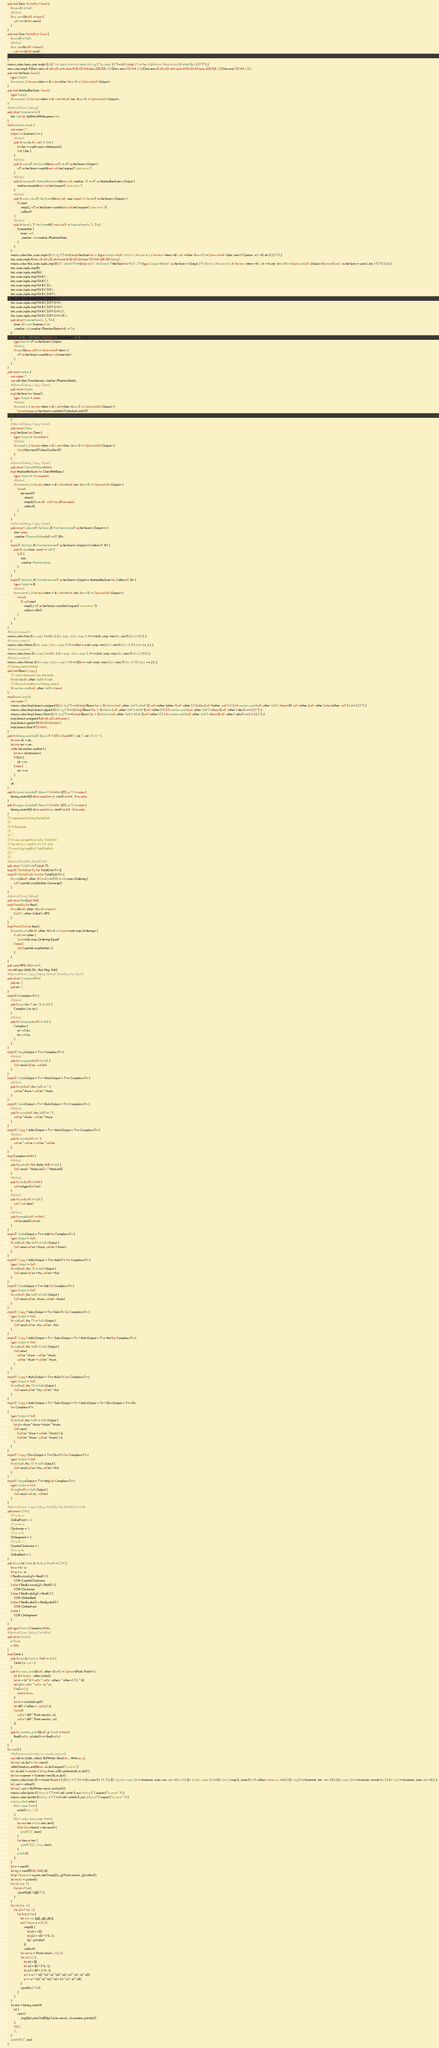<code> <loc_0><loc_0><loc_500><loc_500><_Rust_>pub trait Zero: PartialEq + Sized {
    fn zero() -> Self;
    #[inline]
    fn is_zero(&self) -> bool {
        self == &Self::zero()
    }
}
pub trait One: PartialEq + Sized {
    fn one() -> Self;
    #[inline]
    fn is_one(&self) -> bool {
        self == &Self::one()
    }
}
macro_rules !zero_one_impls {($({$Trait :ident $method :ident $($t :ty ) *,$e :expr } ) *) =>{$($(impl $Trait for $t {#[inline ] fn $method () ->Self {$e } } ) *) *} ;}
zero_one_impls !({Zero zero u8 u16 u32 u64 usize i8 i16 i32 i64 isize u128 i128 ,0 } {Zero zero f32 f64 ,0. } {One one u8 u16 u32 u64 usize i8 i16 i32 i64 isize u128 i128 ,1 } {One one f32 f64 ,1. } ) ;
pub trait IterScan: Sized {
    type Output;
    fn scan<'a, I: Iterator<Item = &'a str>>(iter: &mut I) -> Option<Self::Output>;
}
pub trait MarkedIterScan: Sized {
    type Output;
    fn mscan<'a, I: Iterator<Item = &'a str>>(self, iter: &mut I) -> Option<Self::Output>;
}
#[derive(Clone, Debug)]
pub struct Scanner<'a> {
    iter: std::str::SplitAsciiWhitespace<'a>,
}
mod scanner_impls {
    use super::*;
    impl<'a> Scanner<'a> {
        #[inline]
        pub fn new(s: &'a str) -> Self {
            let iter = s.split_ascii_whitespace();
            Self { iter }
        }
        #[inline]
        pub fn scan<T: IterScan>(&mut self) -> <T as IterScan>::Output {
            <T as IterScan>::scan(&mut self.iter).expect("scan error")
        }
        #[inline]
        pub fn mscan<T: MarkedIterScan>(&mut self, marker: T) -> <T as MarkedIterScan>::Output {
            marker.mscan(&mut self.iter).expect("scan error")
        }
        #[inline]
        pub fn scan_vec<T: IterScan>(&mut self, size: usize) -> Vec<<T as IterScan>::Output> {
            (0..size)
                .map(|_| <T as IterScan>::scan(&mut self.iter).expect("scan error"))
                .collect()
        }
        #[inline]
        pub fn iter<'b, T: IterScan>(&'b mut self) -> ScannerIter<'a, 'b, T> {
            ScannerIter {
                inner: self,
                _marker: std::marker::PhantomData,
            }
        }
    }
    macro_rules !iter_scan_impls {($($t :ty ) *) =>{$(impl IterScan for $t {type Output =Self ;#[inline ] fn scan <'a ,I :Iterator <Item =&'a str >>(iter :&mut I ) ->Option <Self >{iter .next () ?.parse ::<$t >() .ok () } } ) *} ;}
    iter_scan_impls !(char u8 u16 u32 u64 usize i8 i16 i32 i64 isize f32 f64 u128 i128 String ) ;
    macro_rules !iter_scan_tuple_impl {($($T :ident ) *) =>{impl <$($T :IterScan ) ,*>IterScan for ($($T ,) *) {type Output =($(<$T as IterScan >::Output ,) *) ;#[inline ] fn scan <'a ,It :Iterator <Item =&'a str >>(_iter :&mut It ) ->Option <Self ::Output >{Some (($(<$T as IterScan >::scan (_iter ) ?,) *) ) } } } ;}
    iter_scan_tuple_impl!();
    iter_scan_tuple_impl!(A);
    iter_scan_tuple_impl !(A B ) ;
    iter_scan_tuple_impl !(A B C ) ;
    iter_scan_tuple_impl !(A B C D ) ;
    iter_scan_tuple_impl !(A B C D E ) ;
    iter_scan_tuple_impl !(A B C D E F ) ;
    iter_scan_tuple_impl !(A B C D E F G ) ;
    iter_scan_tuple_impl !(A B C D E F G H ) ;
    iter_scan_tuple_impl !(A B C D E F G H I ) ;
    iter_scan_tuple_impl !(A B C D E F G H I J ) ;
    iter_scan_tuple_impl !(A B C D E F G H I J K ) ;
    pub struct ScannerIter<'a, 'b, T> {
        inner: &'b mut Scanner<'a>,
        _marker: std::marker::PhantomData<fn() -> T>,
    }
    impl<'a, 'b, T: IterScan> Iterator for ScannerIter<'a, 'b, T> {
        type Item = <T as IterScan>::Output;
        #[inline]
        fn next(&mut self) -> Option<Self::Item> {
            <T as IterScan>::scan(&mut self.inner.iter)
        }
    }
}
pub mod marker {
    use super::*;
    use std::{iter::FromIterator, marker::PhantomData};
    #[derive(Debug, Copy, Clone)]
    pub struct Usize1;
    impl IterScan for Usize1 {
        type Output = usize;
        #[inline]
        fn scan<'a, I: Iterator<Item = &'a str>>(iter: &mut I) -> Option<Self::Output> {
            Some(<usize as IterScan>::scan(iter)?.checked_sub(1)?)
        }
    }
    #[derive(Debug, Copy, Clone)]
    pub struct Chars;
    impl IterScan for Chars {
        type Output = Vec<char>;
        #[inline]
        fn scan<'a, I: Iterator<Item = &'a str>>(iter: &mut I) -> Option<Self::Output> {
            Some(iter.next()?.chars().collect())
        }
    }
    #[derive(Debug, Copy, Clone)]
    pub struct CharsWithBase(char);
    impl MarkedIterScan for CharsWithBase {
        type Output = Vec<usize>;
        #[inline]
        fn mscan<'a, I: Iterator<Item = &'a str>>(self, iter: &mut I) -> Option<Self::Output> {
            Some(
                iter.next()?
                    .chars()
                    .map(|c| (c as u8 - self.0 as u8) as usize)
                    .collect(),
            )
        }
    }
    #[derive(Debug, Copy, Clone)]
    pub struct Collect<T: IterScan, B: FromIterator<<T as IterScan>::Output>> {
        size: usize,
        _marker: PhantomData<fn() -> (T, B)>,
    }
    impl<T: IterScan, B: FromIterator<<T as IterScan>::Output>> Collect<T, B> {
        pub fn new(size: usize) -> Self {
            Self {
                size,
                _marker: PhantomData,
            }
        }
    }
    impl<T: IterScan, B: FromIterator<<T as IterScan>::Output>> MarkedIterScan for Collect<T, B> {
        type Output = B;
        #[inline]
        fn mscan<'a, I: Iterator<Item = &'a str>>(self, iter: &mut I) -> Option<Self::Output> {
            Some(
                (0..self.size)
                    .map(|_| <T as IterScan>::scan(iter).expect("scan error"))
                    .collect::<B>(),
            )
        }
    }
}
#[macro_export]
macro_rules !min {($e :expr ) =>{$e } ;($e :expr ,$($es :expr ) ,+) =>{std ::cmp ::min ($e ,min !($($es ) ,+) ) } ;}
#[macro_export]
macro_rules !chmin {($dst :expr ,$($src :expr ) ,+) =>{{let x =std ::cmp ::min ($dst ,min !($($src ) ,+) ) ;$dst =x ;} } ;}
#[macro_export]
macro_rules !max {($e :expr ) =>{$e } ;($e :expr ,$($es :expr ) ,+) =>{std ::cmp ::max ($e ,max !($($es ) ,+) ) } ;}
#[macro_export]
macro_rules !chmax {($dst :expr ,$($src :expr ) ,+) =>{{let x =std ::cmp ::max ($dst ,max !($($src ) ,+) ) ;$dst =x ;} } ;}
/// binary search helper
pub trait Bisect: Copy {
    /// return between two elements
    fn halve(self, other: Self) -> Self;
    /// the end condition of binary search
    fn section_end(self, other: Self) -> bool;
}
mod bisect_impl {
    use super::*;
    macro_rules !impl_bisect_unsigned {($($t :ty ) *) =>{$(impl Bisect for $t {fn halve (self ,other :Self ) ->Self {if self >other {other +(self -other ) /2 } else {self +(other -self ) /2 } } fn section_end (self ,other :Self ) ->bool {(if self >other {self -other } else {other -self } ) <=1 } } ) *} ;}
    macro_rules !impl_bisect_signed {($($t :ty ) *) =>{$(impl Bisect for $t {fn halve (self ,other :Self ) ->Self {(self +other ) /2 } fn section_end (self ,other :Self ) ->bool {(self -other ) .abs () <=1 } } ) *} ;}
    macro_rules !impl_bisect_float {($($t :ty ) *) =>{$(impl Bisect for $t {fn halve (self ,other :Self ) ->Self {(self +other ) /2. } fn section_end (self ,other :Self ) ->bool {(self -other ) .abs () <=1e-8 } } ) *} ;}
    impl_bisect_unsigned !(u8 u16 u32 u64 usize ) ;
    impl_bisect_signed !(i8 i16 i32 i64 isize ) ;
    impl_bisect_float !(f32 f64 ) ;
}
pub fn binary_search<T: Bisect, F: Fn(T) -> bool>(f: F, ok: T, err: T) -> T {
    let mut ok = ok;
    let mut err = err;
    while !ok.section_end(err) {
        let m = ok.halve(err);
        if f(m) {
            ok = m;
        } else {
            err = m;
        }
    }
    ok
}
pub fn lower_bound<T: Bisect + Ord>(v: &[T], x: T) -> usize {
    binary_search(|i| v[i as usize] >= x, v.len() as i64, -1) as usize
}
pub fn upper_bound<T: Bisect + Ord>(v: &[T], x: T) -> usize {
    binary_search(|i| v[i as usize] > x, v.len() as i64, -1) as usize
}
/// implement Ord by PartialOrd
///
/// # Example
///
/// ```
/// # use competitive::tools::TotalOrd;
/// let mut a = vec![3.1, 4.1, 5.9, 2.6];
/// a.sort_by_key(|&x| TotalOrd(x));
/// ```
///
#[derive(PartialEq, PartialOrd)]
pub struct TotalOrd<T>(pub T);
impl<T: PartialEq> Eq for TotalOrd<T> {}
impl<T: PartialOrd> Ord for TotalOrd<T> {
    fn cmp(&self, other: &TotalOrd<T>) -> std::cmp::Ordering {
        self.0.partial_cmp(&other.0).unwrap()
    }
}
#[derive(Clone, Debug)]
pub struct Real(pub f64);
impl PartialEq for Real {
    fn eq(&self, other: &Real) -> bool {
        (self.0 - other.0).abs() < EPS
    }
}
impl PartialOrd for Real {
    fn partial_cmp(&self, other: &Real) -> Option<std::cmp::Ordering> {
        if self == other {
            Some(std::cmp::Ordering::Equal)
        } else {
            self.0.partial_cmp(&other.0)
        }
    }
}
pub const EPS: f64 = 1e-8;
use std::ops::{Add, Div, Mul, Neg, Sub};
#[derive(Clone, Copy, Debug, Default, PartialEq, Eq, Hash)]
pub struct Complex<T> {
    pub re: T,
    pub im: T,
}
impl<T> Complex<T> {
    #[inline]
    pub fn new(re: T, im: T) -> Self {
        Complex { re, im }
    }
    #[inline]
    pub fn transpose(self) -> Self {
        Complex {
            re: self.im,
            im: self.re,
        }
    }
}
impl<T: Neg<Output = T>> Complex<T> {
    #[inline]
    pub fn conjugate(self) -> Self {
        Self::new(self.re, -self.im)
    }
}
impl<T: Add<Output = T> + Mul<Output = T>> Complex<T> {
    #[inline]
    pub fn dot(self, rhs: Self) -> T {
        self.re * rhs.re + self.im * rhs.im
    }
}
impl<T: Sub<Output = T> + Mul<Output = T>> Complex<T> {
    #[inline]
    pub fn cross(self, rhs: Self) -> T {
        self.re * rhs.im - self.im * rhs.re
    }
}
impl<T: Copy + Add<Output = T> + Mul<Output = T>> Complex<T> {
    #[inline]
    pub fn norm(self) -> T {
        self.re * self.re + self.im * self.im
    }
}
impl Complex<f64> {
    #[inline]
    pub fn polar(r: f64, theta: f64) -> Self {
        Self::new(r * theta.cos(), r * theta.sin())
    }
    #[inline]
    pub fn abs(self) -> f64 {
        self.re.hypot(self.im)
    }
    #[inline]
    pub fn unit(self) -> Self {
        self / self.abs()
    }
    #[inline]
    pub fn angle(self) -> f64 {
        self.im.atan2(self.re)
    }
}
impl<T: Add<Output = T>> Add for Complex<T> {
    type Output = Self;
    fn add(self, rhs: Self) -> Self::Output {
        Self::new(self.re + rhs.re, self.im + rhs.im)
    }
}
impl<T: Copy + Add<Output = T>> Add<T> for Complex<T> {
    type Output = Self;
    fn add(self, rhs: T) -> Self::Output {
        Self::new(self.re + rhs, self.im + rhs)
    }
}
impl<T: Sub<Output = T>> Sub for Complex<T> {
    type Output = Self;
    fn sub(self, rhs: Self) -> Self::Output {
        Self::new(self.re - rhs.re, self.im - rhs.im)
    }
}
impl<T: Copy + Sub<Output = T>> Sub<T> for Complex<T> {
    type Output = Self;
    fn sub(self, rhs: T) -> Self::Output {
        Self::new(self.re - rhs, self.im - rhs)
    }
}
impl<T: Copy + Add<Output = T> + Sub<Output = T> + Mul<Output = T>> Mul for Complex<T> {
    type Output = Self;
    fn mul(self, rhs: Self) -> Self::Output {
        Self::new(
            self.re * rhs.re - self.im * rhs.im,
            self.re * rhs.im + self.im * rhs.re,
        )
    }
}
impl<T: Copy + Mul<Output = T>> Mul<T> for Complex<T> {
    type Output = Self;
    fn mul(self, rhs: T) -> Self::Output {
        Self::new(self.re * rhs, self.im * rhs)
    }
}
impl<T: Copy + Add<Output = T> + Sub<Output = T> + Mul<Output = T> + Div<Output = T>> Div
    for Complex<T>
{
    type Output = Self;
    fn div(self, rhs: Self) -> Self::Output {
        let d = rhs.re * rhs.re + rhs.im * rhs.im;
        Self::new(
            (self.re * rhs.re + self.im * rhs.im) / d,
            (self.im * rhs.re - self.re * rhs.im) / d,
        )
    }
}
impl<T: Copy + Div<Output = T>> Div<T> for Complex<T> {
    type Output = Self;
    fn div(self, rhs: T) -> Self::Output {
        Self::new(self.re / rhs, self.im / rhs)
    }
}
impl<T: Neg<Output = T>> Neg for Complex<T> {
    type Output = Self;
    fn neg(self) -> Self::Output {
        Self::new(-self.re, -self.im)
    }
}
#[derive(Clone, Copy, Debug, PartialEq, Eq, PartialOrd, Ord)]
pub enum CCW {
    /// a--b--c
    OnlineFront = -2,
    /// a--b-vc
    Clockwise = -1,
    /// a--c--b
    OnSegment = 0,
    /// a--b-^c
    CounterClockwise = 1,
    /// c--a--b
    OnlineBack = 2,
}
pub fn ccw(a: Point, b: Point, c: Point) -> CCW {
    let x = b - a;
    let y = c - a;
    if Real(x.cross(y)) > Real(0.) {
        CCW::CounterClockwise
    } else if Real(x.cross(y)) < Real(0.) {
        CCW::Clockwise
    } else if Real(x.dot(y)) < Real(0.) {
        CCW::OnlineBack
    } else if Real(x.abs()) < Real(y.abs()) {
        CCW::OnlineFront
    } else {
        CCW::OnSegment
    }
}
pub type Point = Complex<f64>;
#[derive(Clone, Debug, PartialEq)]
pub struct Circle {
    c: Point,
    r: f64,
}
impl Circle {
    pub fn new(c: Point, r: f64) -> Self {
        Circle { c: c, r: r }
    }
    pub fn cross_circle(&self, other: &Self) -> Option<(Point, Point)> {
        let d = (self.c - other.c).abs();
        let rc = (d * d + self.r * self.r - other.r * other.r) / (2. * d);
        let rs2 = self.r * self.r - rc * rc;
        if rs2 < 0. {
            return None;
        }
        let rs = rs2.abs().sqrt();
        let diff = (other.c - self.c) / d;
        Some((
            self.c + diff * Point::new(rc, rs),
            self.c + diff * Point::new(rc, -rs),
        ))
    }
    pub fn contains_point(&self, p: Point) -> bool {
        Real((self.c - p).abs()) <= Real(self.r)
    }
}
fn main() {
    #![allow(unused_imports, unused_macros)]
    use std::io::{stdin, stdout, BufWriter, Read as _, Write as _};
    let mut _in_buf = Vec::new();
    stdin().read_to_end(&mut _in_buf).expect("io error");
    let _in_buf = unsafe { String::from_utf8_unchecked(_in_buf) };
    let mut scanner = Scanner::new(&_in_buf);
    macro_rules !scan {() =>{scan !(usize ) } ;(($($t :tt ) ,*) ) =>{($(scan !($t ) ) ,*) } ;([$t :ty ;$len :expr ] ) =>{scanner .scan_vec ::<$t >($len ) } ;([$t :tt ;$len :expr ] ) =>{(0 ..$len ) .map (|_ |scan !($t ) ) .collect ::<Vec <_ >>() } ;([$t :ty ] ) =>{scanner .iter ::<$t >() } ;({$e :expr } ) =>{scanner .mscan ($e ) } ;($t :ty ) =>{scanner .scan ::<$t >() } ;}
    let _out = stdout();
    let mut _out = BufWriter::new(_out.lock());
    macro_rules !print {($($arg :tt ) *) =>(::std ::write !(_out ,$($arg ) *) .expect ("io error" ) ) }
    macro_rules !println {($($arg :tt ) *) =>(::std ::writeln !(_out ,$($arg ) *) .expect ("io error" ) ) }
    macro_rules! echo {
        ($iter :expr ) => {
            echo!($iter, '\n')
        };
        ($iter :expr ,$sep :expr ) => {
            let mut iter = $iter.into_iter();
            if let Some(item) = iter.next() {
                print!("{}", item);
            }
            for item in iter {
                print!("{}{}", $sep, item);
            }
            println!();
        };
    }
    let n = scan!();
    let xy = scan!([(f64, f64); n]);
    let p: Vec<_> = xy.into_iter().map(|(x, y)| Point::new(x, y)).collect();
    let mut c = p.clone();
    for i in 0..n - 1 {
        for j in i + 1..n {
            c.push((p[i] + p[j]) / 2.);
        }
    }
    for i in 0..n - 2 {
        for j in i + 1..n - 1 {
            for k in j + 1..n {
                let v = vec![p[i], p[j], p[k]];
                let l: Vec<_> = (0..3)
                    .map(|i| {
                        let p1 = v[i];
                        let p2 = v[(i + 1) % 3];
                        (p1 - p2).abs()
                    })
                    .collect();
                let mut x = (Point::new(0., 0.), 0.);
                for i in 0..3 {
                    let a1 = l[i];
                    let a2 = l[(i + 1) % 3];
                    let a3 = l[(i + 2) % 3];
                    x.0 = x.0 + v[i] * (a1 * a1 * (a2 * a2 + a3 * a3 - a1 * a1));
                    x.1 = x.1 + (a1 * a1 * (a2 * a2 + a3 * a3 - a1 * a1));
                }
                c.push(x.0 / x.1);
            }
        }
    }
    let ans = binary_search(
        |x| {
            c.iter()
                .any(|&c| p.iter().all(|&p| Circle::new(c, x).contains_point(p)))
        },
        1000.,
        0.,
    );
    println!("{}", ans);
}</code> 